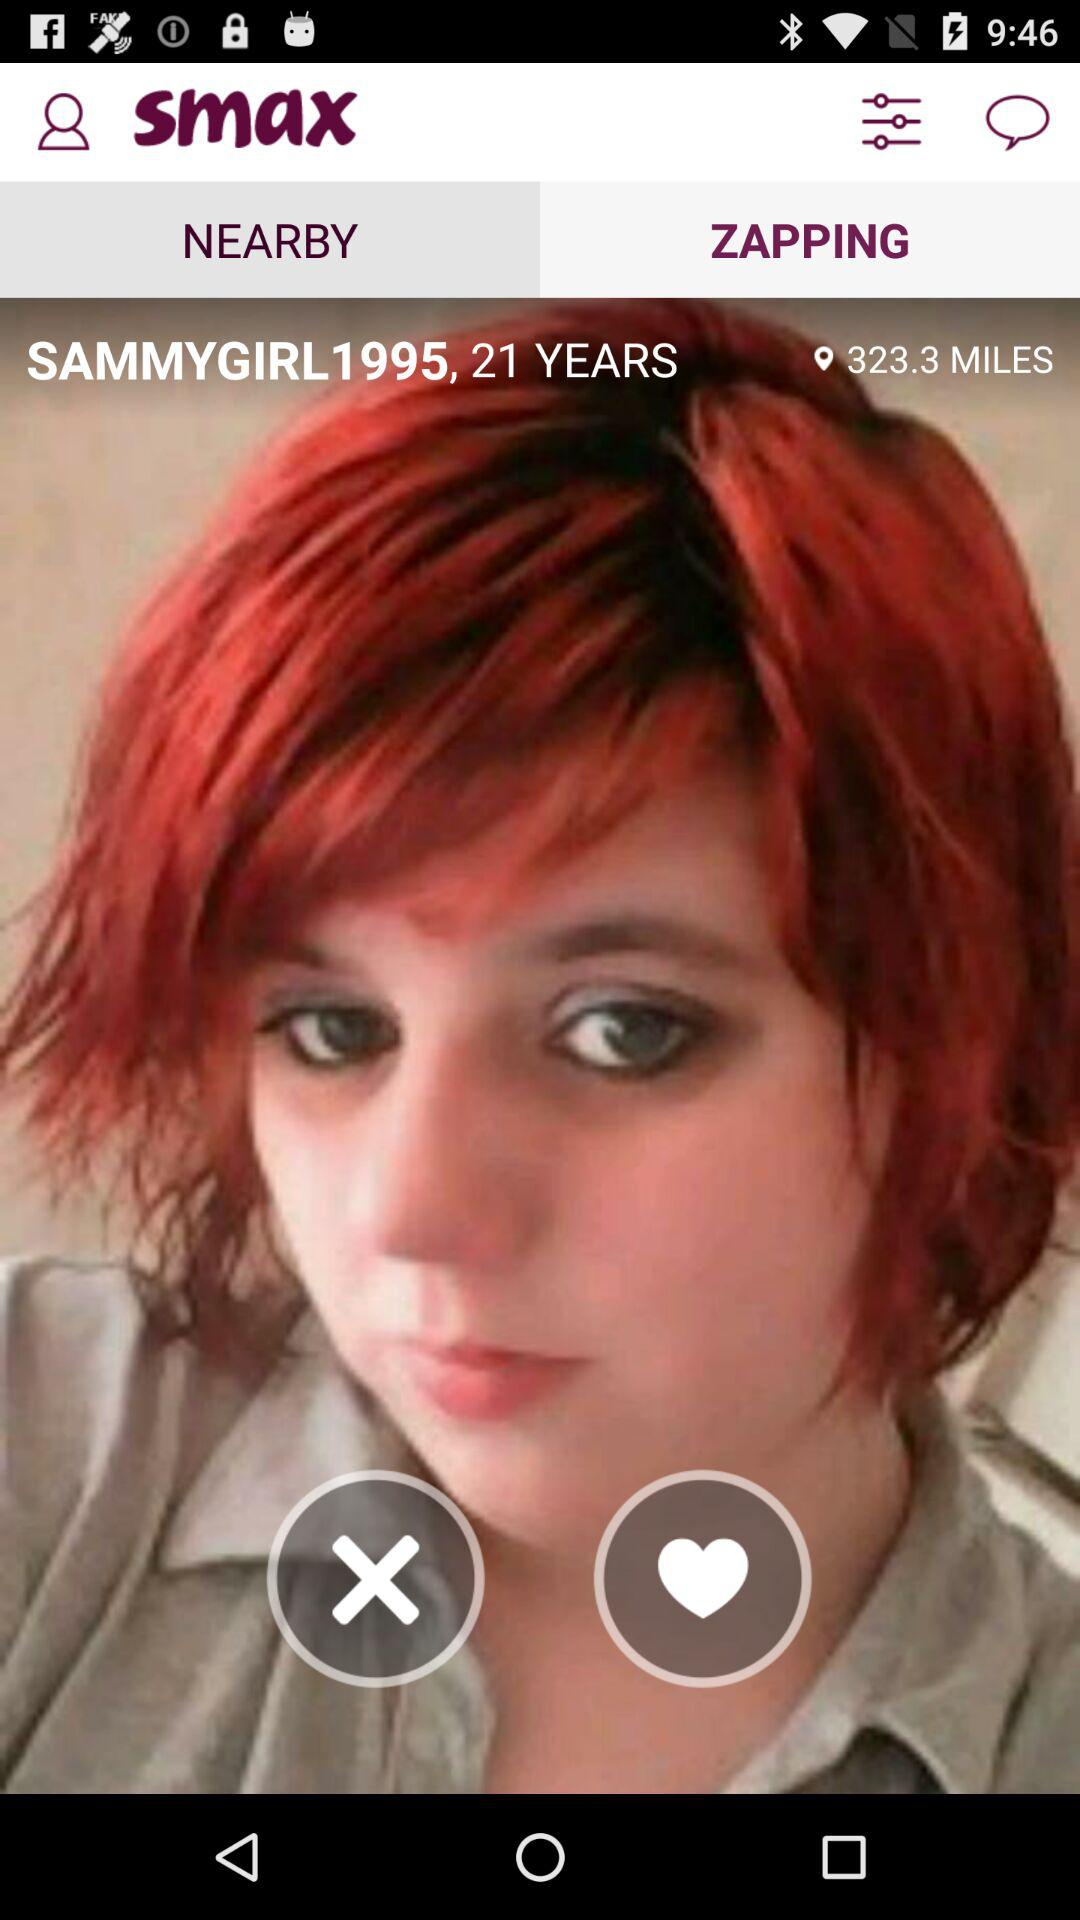How many miles are there? There are 323.3 miles. 